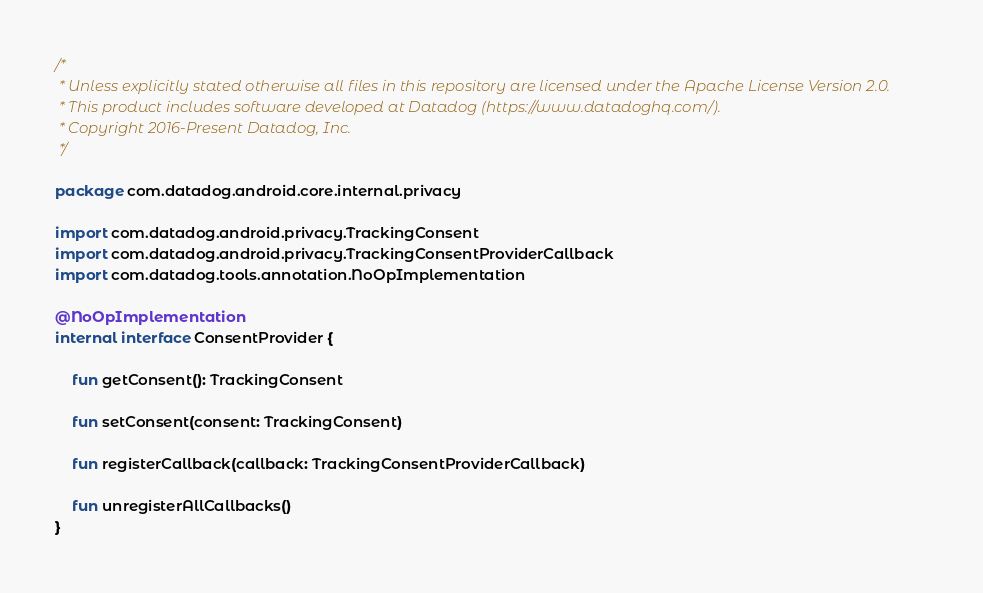<code> <loc_0><loc_0><loc_500><loc_500><_Kotlin_>/*
 * Unless explicitly stated otherwise all files in this repository are licensed under the Apache License Version 2.0.
 * This product includes software developed at Datadog (https://www.datadoghq.com/).
 * Copyright 2016-Present Datadog, Inc.
 */

package com.datadog.android.core.internal.privacy

import com.datadog.android.privacy.TrackingConsent
import com.datadog.android.privacy.TrackingConsentProviderCallback
import com.datadog.tools.annotation.NoOpImplementation

@NoOpImplementation
internal interface ConsentProvider {

    fun getConsent(): TrackingConsent

    fun setConsent(consent: TrackingConsent)

    fun registerCallback(callback: TrackingConsentProviderCallback)

    fun unregisterAllCallbacks()
}
</code> 